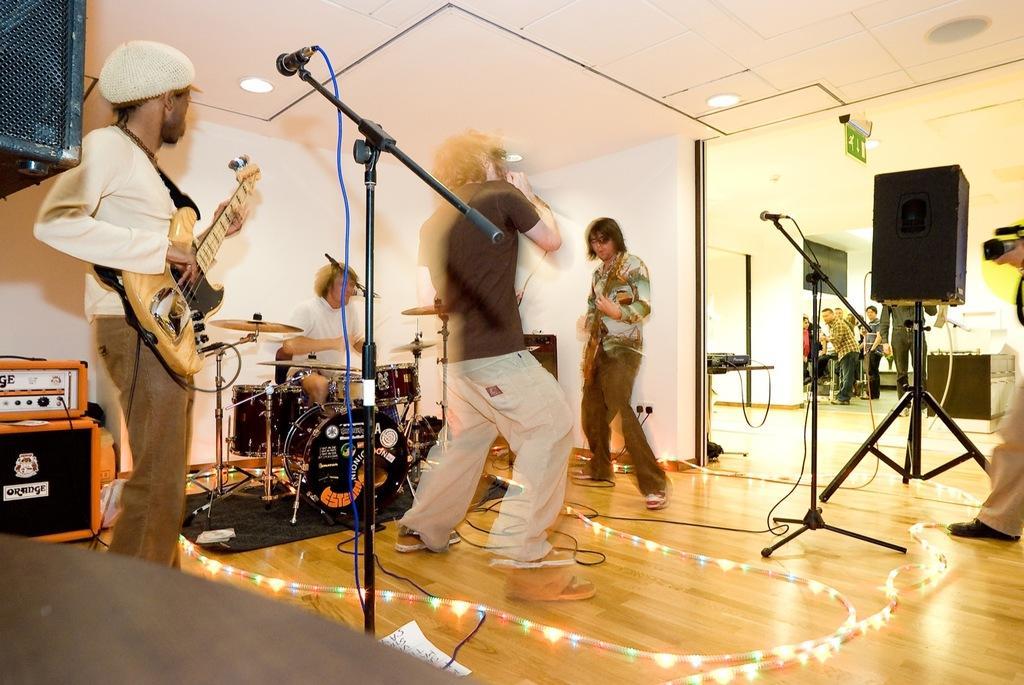Describe this image in one or two sentences. In this image there are three persons who are standing on the left side the person who is standing and he is holding a guitar, in front of him there is one mike. In the center there is one person who is standing and he is holding a mike it seems that he is singing beside him there is one person who is standing and he is holding a guitar and in the center there is one man who is sitting. In front of him there are some drums. On the top there is ceiling and some lights are there and on the right side there is one speaker and one mike and a group of people are there and on the floor there are some lights. 